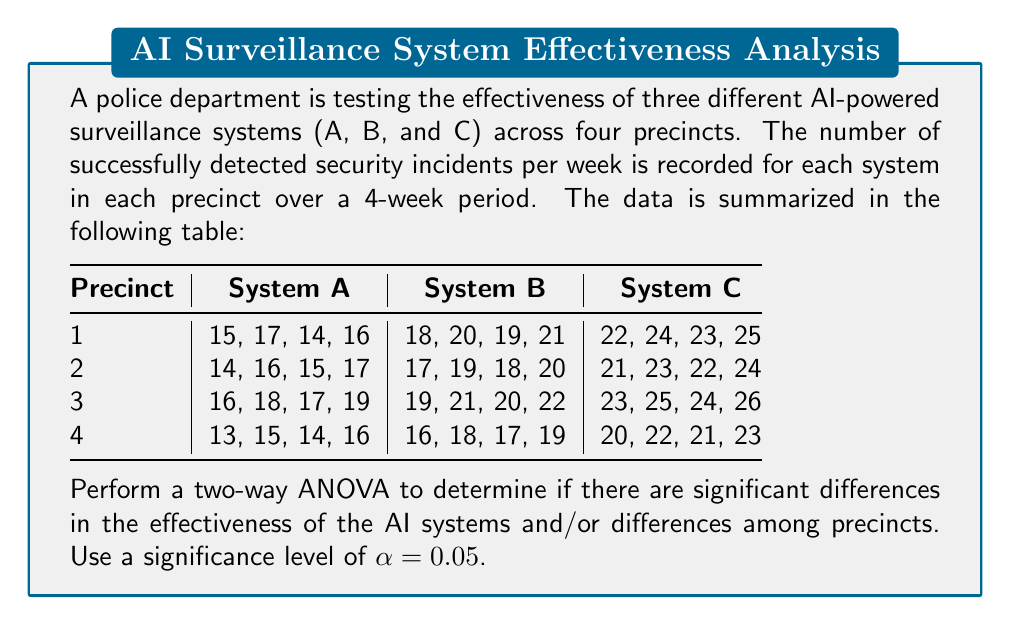Show me your answer to this math problem. To perform a two-way ANOVA, we need to follow these steps:

1. Calculate the total sum of squares (SST)
2. Calculate the sum of squares for factor A (SSA) - AI systems
3. Calculate the sum of squares for factor B (SSB) - Precincts
4. Calculate the sum of squares for interaction (SSAB)
5. Calculate the sum of squares for error (SSE)
6. Calculate the degrees of freedom for each source of variation
7. Calculate the mean squares
8. Calculate the F-ratios
9. Compare F-ratios with critical F-values

Step 1: Calculate SST

First, we need to calculate the grand mean:
$$\bar{X} = \frac{\text{Sum of all observations}}{\text{Total number of observations}} = \frac{912}{48} = 19$$

SST = $\sum_{i=1}^{n} (X_i - \bar{X})^2 = 1008$

Step 2: Calculate SSA (AI systems)

$$SSA = 4 \times 4 \times \sum_{i=1}^{3} (\bar{X_i} - \bar{X})^2 = 768$$

Step 3: Calculate SSB (Precincts)

$$SSB = 3 \times 4 \times \sum_{j=1}^{4} (\bar{X_j} - \bar{X})^2 = 32$$

Step 4: Calculate SSAB (Interaction)

$$SSAB = 4 \times \sum_{i=1}^{3} \sum_{j=1}^{4} (\bar{X_{ij}} - \bar{X_i} - \bar{X_j} + \bar{X})^2 = 0$$

Step 5: Calculate SSE (Error)

$$SSE = SST - SSA - SSB - SSAB = 1008 - 768 - 32 - 0 = 208$$

Step 6: Degrees of freedom

- dfA = 3 - 1 = 2
- dfB = 4 - 1 = 3
- dfAB = dfA × dfB = 6
- dfE = 48 - (3 × 4) = 36
- dfT = 48 - 1 = 47

Step 7: Mean squares

$$MSA = \frac{SSA}{dfA} = \frac{768}{2} = 384$$
$$MSB = \frac{SSB}{dfB} = \frac{32}{3} = 10.67$$
$$MSAB = \frac{SSAB}{dfAB} = \frac{0}{6} = 0$$
$$MSE = \frac{SSE}{dfE} = \frac{208}{36} = 5.78$$

Step 8: F-ratios

$$F_A = \frac{MSA}{MSE} = \frac{384}{5.78} = 66.44$$
$$F_B = \frac{MSB}{MSE} = \frac{10.67}{5.78} = 1.85$$
$$F_{AB} = \frac{MSAB}{MSE} = \frac{0}{5.78} = 0$$

Step 9: Compare with critical F-values

At α = 0.05:
- F(2, 36) ≈ 3.26
- F(3, 36) ≈ 2.87
- F(6, 36) ≈ 2.38

Conclusions:
- For AI systems: 66.44 > 3.26, so there are significant differences in effectiveness.
- For Precincts: 1.85 < 2.87, so there are no significant differences among precincts.
- For Interaction: 0 < 2.38, so there is no significant interaction effect.
Answer: Significant differences in AI system effectiveness (F = 66.44, p < 0.05). No significant differences among precincts or interaction effects. 